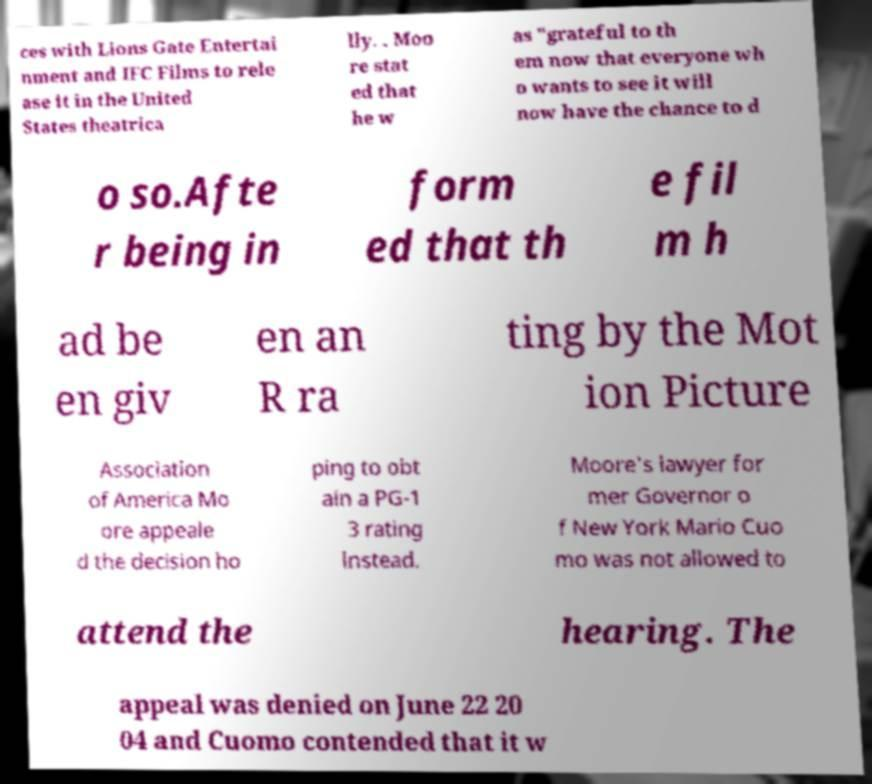What messages or text are displayed in this image? I need them in a readable, typed format. ces with Lions Gate Entertai nment and IFC Films to rele ase it in the United States theatrica lly. . Moo re stat ed that he w as "grateful to th em now that everyone wh o wants to see it will now have the chance to d o so.Afte r being in form ed that th e fil m h ad be en giv en an R ra ting by the Mot ion Picture Association of America Mo ore appeale d the decision ho ping to obt ain a PG-1 3 rating instead. Moore's lawyer for mer Governor o f New York Mario Cuo mo was not allowed to attend the hearing. The appeal was denied on June 22 20 04 and Cuomo contended that it w 